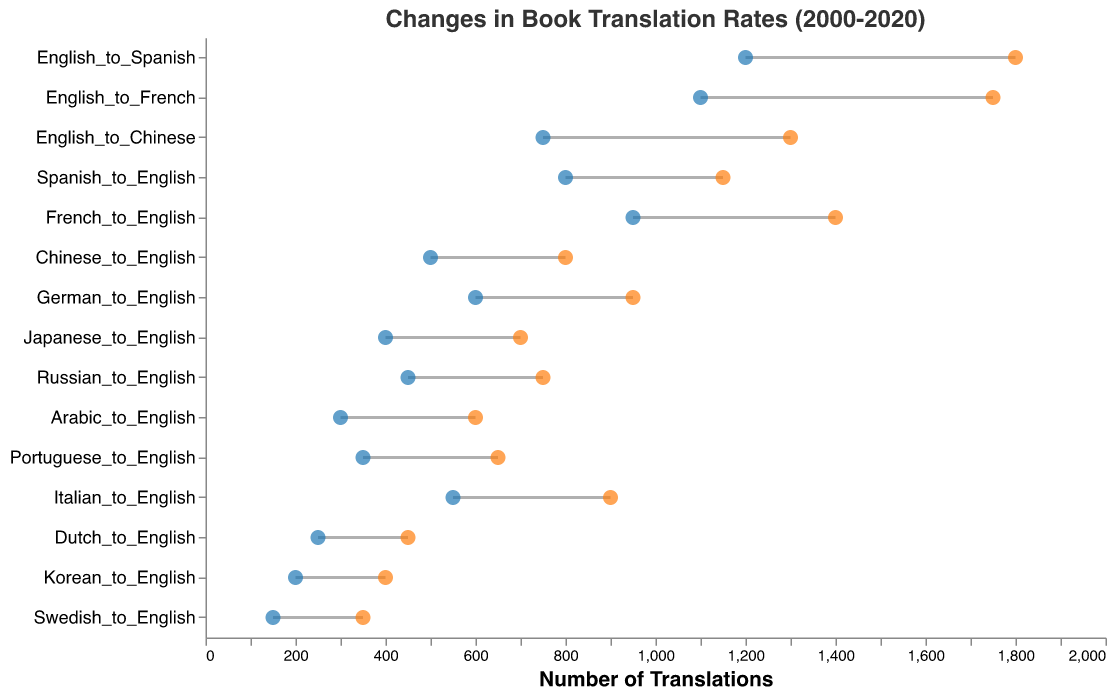What is the title of the figure? The title of the figure is usually displayed at the top of the plot. In this case, the title text is "Changes in Book Translation Rates (2000-2020)", which indicates the content and time period covered by the figure.
Answer: Changes in Book Translation Rates (2000-2020) Which language pair had the highest number of translations in 2020? To find this, look at the rightmost points on the graph and see which language pair they correspond to. The one with the highest position on the x-axis in 2020 is "English_to_Spanish". This is because it lies furthest to the right on the scale, indicating the highest number in 2020.
Answer: English_to_Spanish Which language showed the greatest increase in translations from 2000 to 2020? This can be found by looking at the length of the lines connecting the points for each language. The longest line represents the greatest increase. The "English_to_Spanish" line is the longest, going from 1200 in 2000 to 1800 in 2020, an increase of 600 translations.
Answer: English_to_Spanish How many more translations from Japanese to English were there in 2020 compared to 2000? Find the points corresponding to "Japanese_to_English" for both years. In 2000, it had 400 translations, and in 2020, it had 700. The difference is 700 - 400 = 300 translations.
Answer: 300 Which language pair had the least increase in translations from 2000 to 2020? The shortest line indicates the least increase. By looking closely, "Dutch_to_English" shows the least increase, moving from 250 in 2000 to 450 in 2020, which is an increase of 200 translations.
Answer: Dutch_to_English How many language pairs had translations more than 1000 in 2020? Count the rightmost points that lie above the 1000 mark on the x-axis. The language pairs are "English_to_Spanish", "English_to_French", "English_to_Chinese", "Spanish_to_English", and "French_to_English". There are 5 such language pairs.
Answer: 5 How much did translations from Arabic to English increase from 2000 to 2020? Find the points for "Arabic_to_English" in both years. In 2000, it was 300 translations and in 2020, it was 600 translations. The increase is 600 - 300 = 300 translations.
Answer: 300 Between English to French and French to English, which had a higher increase in translations? Look at the lines for "English_to_French" and "French_to_English". Calculate their increases: "English_to_French" increased from 1100 to 1750, which is 650, and "French_to_English" increased from 950 to 1400, which is 450. "English_to_French" had a higher increase.
Answer: English_to_French What was the total number of translations for English to Chinese in 2020? Look at the rightmost point for "English_to_Chinese". It is positioned at 1300 on the x-axis. Thus, the total number of translations for English to Chinese in 2020 was 1300.
Answer: 1300 